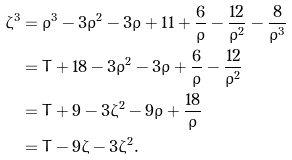<formula> <loc_0><loc_0><loc_500><loc_500>\zeta ^ { 3 } & = \rho ^ { 3 } - 3 \rho ^ { 2 } - 3 \rho + 1 1 + \frac { 6 } { \rho } - \frac { 1 2 } { \rho ^ { 2 } } - \frac { 8 } { \rho ^ { 3 } } \\ & = T + 1 8 - 3 \rho ^ { 2 } - 3 \rho + \frac { 6 } { \rho } - \frac { 1 2 } { \rho ^ { 2 } } \\ & = T + 9 - 3 \zeta ^ { 2 } - 9 \rho + \frac { 1 8 } { \rho } \\ & = T - 9 \zeta - 3 \zeta ^ { 2 } .</formula> 